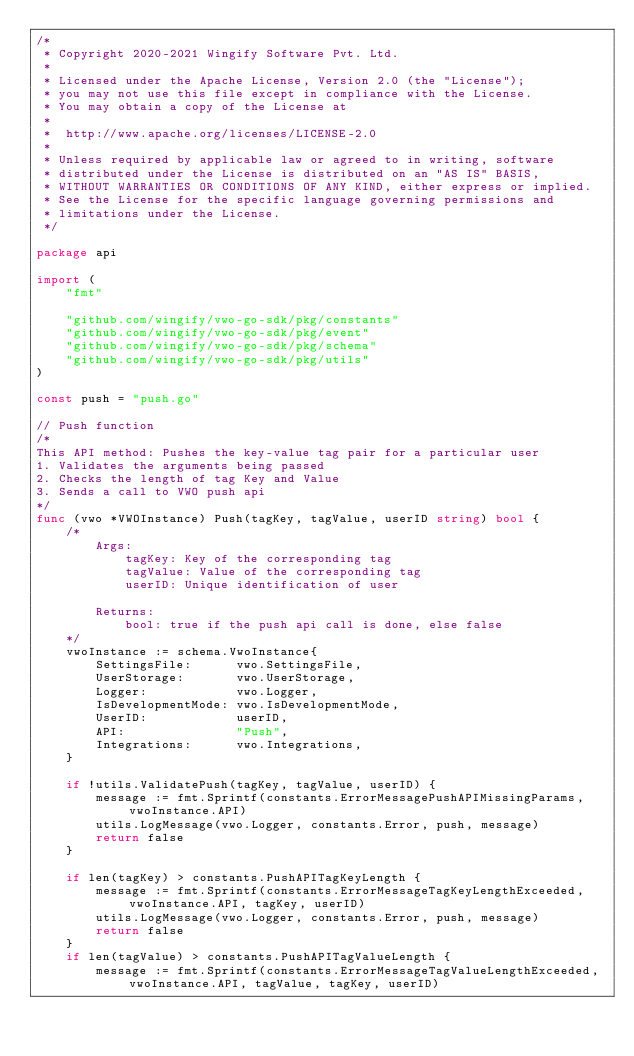Convert code to text. <code><loc_0><loc_0><loc_500><loc_500><_Go_>/*
 * Copyright 2020-2021 Wingify Software Pvt. Ltd.
 *
 * Licensed under the Apache License, Version 2.0 (the "License");
 * you may not use this file except in compliance with the License.
 * You may obtain a copy of the License at
 *
 *  http://www.apache.org/licenses/LICENSE-2.0
 *
 * Unless required by applicable law or agreed to in writing, software
 * distributed under the License is distributed on an "AS IS" BASIS,
 * WITHOUT WARRANTIES OR CONDITIONS OF ANY KIND, either express or implied.
 * See the License for the specific language governing permissions and
 * limitations under the License.
 */

package api

import (
	"fmt"

	"github.com/wingify/vwo-go-sdk/pkg/constants"
	"github.com/wingify/vwo-go-sdk/pkg/event"
	"github.com/wingify/vwo-go-sdk/pkg/schema"
	"github.com/wingify/vwo-go-sdk/pkg/utils"
)

const push = "push.go"

// Push function
/*
This API method: Pushes the key-value tag pair for a particular user
1. Validates the arguments being passed
2. Checks the length of tag Key and Value
3. Sends a call to VWO push api
*/
func (vwo *VWOInstance) Push(tagKey, tagValue, userID string) bool {
	/*
		Args:
			tagKey: Key of the corresponding tag
			tagValue: Value of the corresponding tag
			userID: Unique identification of user

		Returns:
			bool: true if the push api call is done, else false
	*/
	vwoInstance := schema.VwoInstance{
		SettingsFile:      vwo.SettingsFile,
		UserStorage:       vwo.UserStorage,
		Logger:            vwo.Logger,
		IsDevelopmentMode: vwo.IsDevelopmentMode,
		UserID:            userID,
		API:               "Push",
		Integrations:      vwo.Integrations,
	}

	if !utils.ValidatePush(tagKey, tagValue, userID) {
		message := fmt.Sprintf(constants.ErrorMessagePushAPIMissingParams, vwoInstance.API)
		utils.LogMessage(vwo.Logger, constants.Error, push, message)
		return false
	}

	if len(tagKey) > constants.PushAPITagKeyLength {
		message := fmt.Sprintf(constants.ErrorMessageTagKeyLengthExceeded, vwoInstance.API, tagKey, userID)
		utils.LogMessage(vwo.Logger, constants.Error, push, message)
		return false
	}
	if len(tagValue) > constants.PushAPITagValueLength {
		message := fmt.Sprintf(constants.ErrorMessageTagValueLengthExceeded, vwoInstance.API, tagValue, tagKey, userID)</code> 